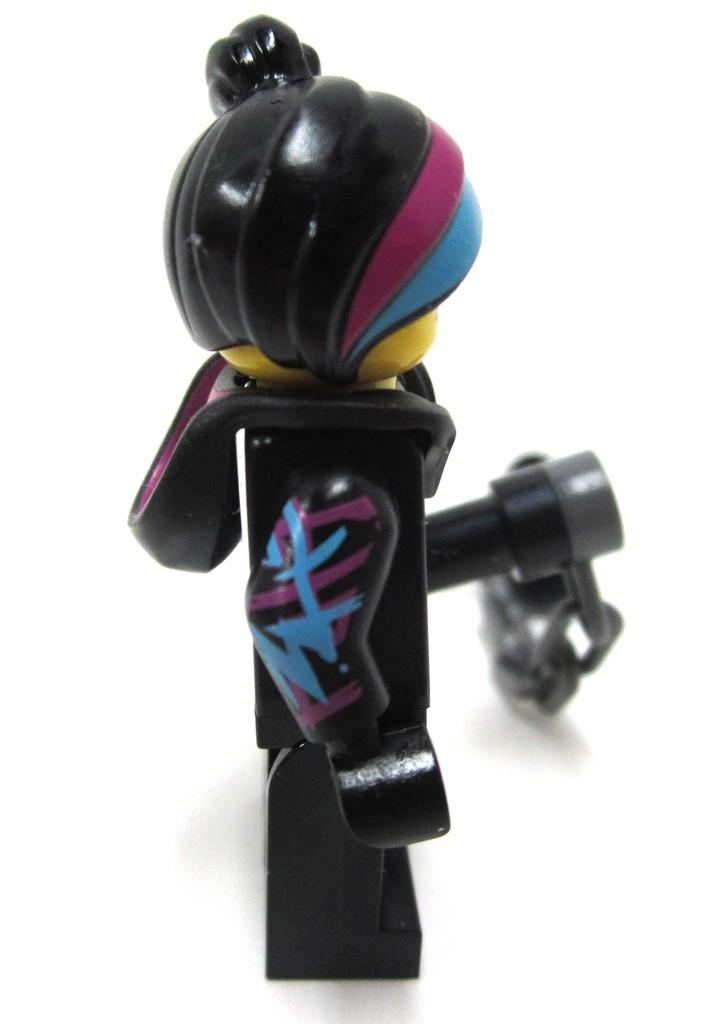What object can be seen in the image? There is a toy in the image. What color is the background of the image? The background of the image is white. What type of cough medicine is being distributed by the ship in the image? There is no ship or cough medicine present in the image; it only features a toy and a white background. 